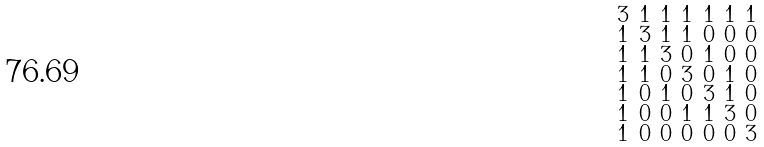Convert formula to latex. <formula><loc_0><loc_0><loc_500><loc_500>\begin{smallmatrix} 3 & 1 & 1 & 1 & 1 & 1 & 1 \\ 1 & 3 & 1 & 1 & 0 & 0 & 0 \\ 1 & 1 & 3 & 0 & 1 & 0 & 0 \\ 1 & 1 & 0 & 3 & 0 & 1 & 0 \\ 1 & 0 & 1 & 0 & 3 & 1 & 0 \\ 1 & 0 & 0 & 1 & 1 & 3 & 0 \\ 1 & 0 & 0 & 0 & 0 & 0 & 3 \end{smallmatrix}</formula> 